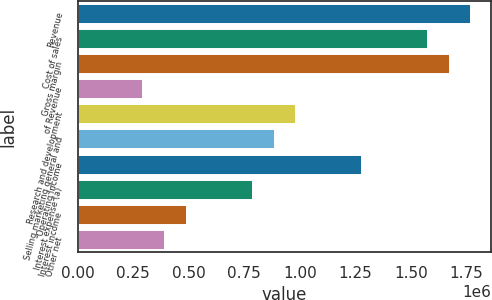<chart> <loc_0><loc_0><loc_500><loc_500><bar_chart><fcel>Revenue<fcel>Cost of sales<fcel>Gross margin<fcel>of Revenue<fcel>Research and development<fcel>Selling marketing general and<fcel>Operating income<fcel>Interest expense (a)<fcel>Interest income<fcel>Other net<nl><fcel>1.77201e+06<fcel>1.57512e+06<fcel>1.67356e+06<fcel>295335<fcel>984449<fcel>886004<fcel>1.27978e+06<fcel>787559<fcel>492225<fcel>393780<nl></chart> 